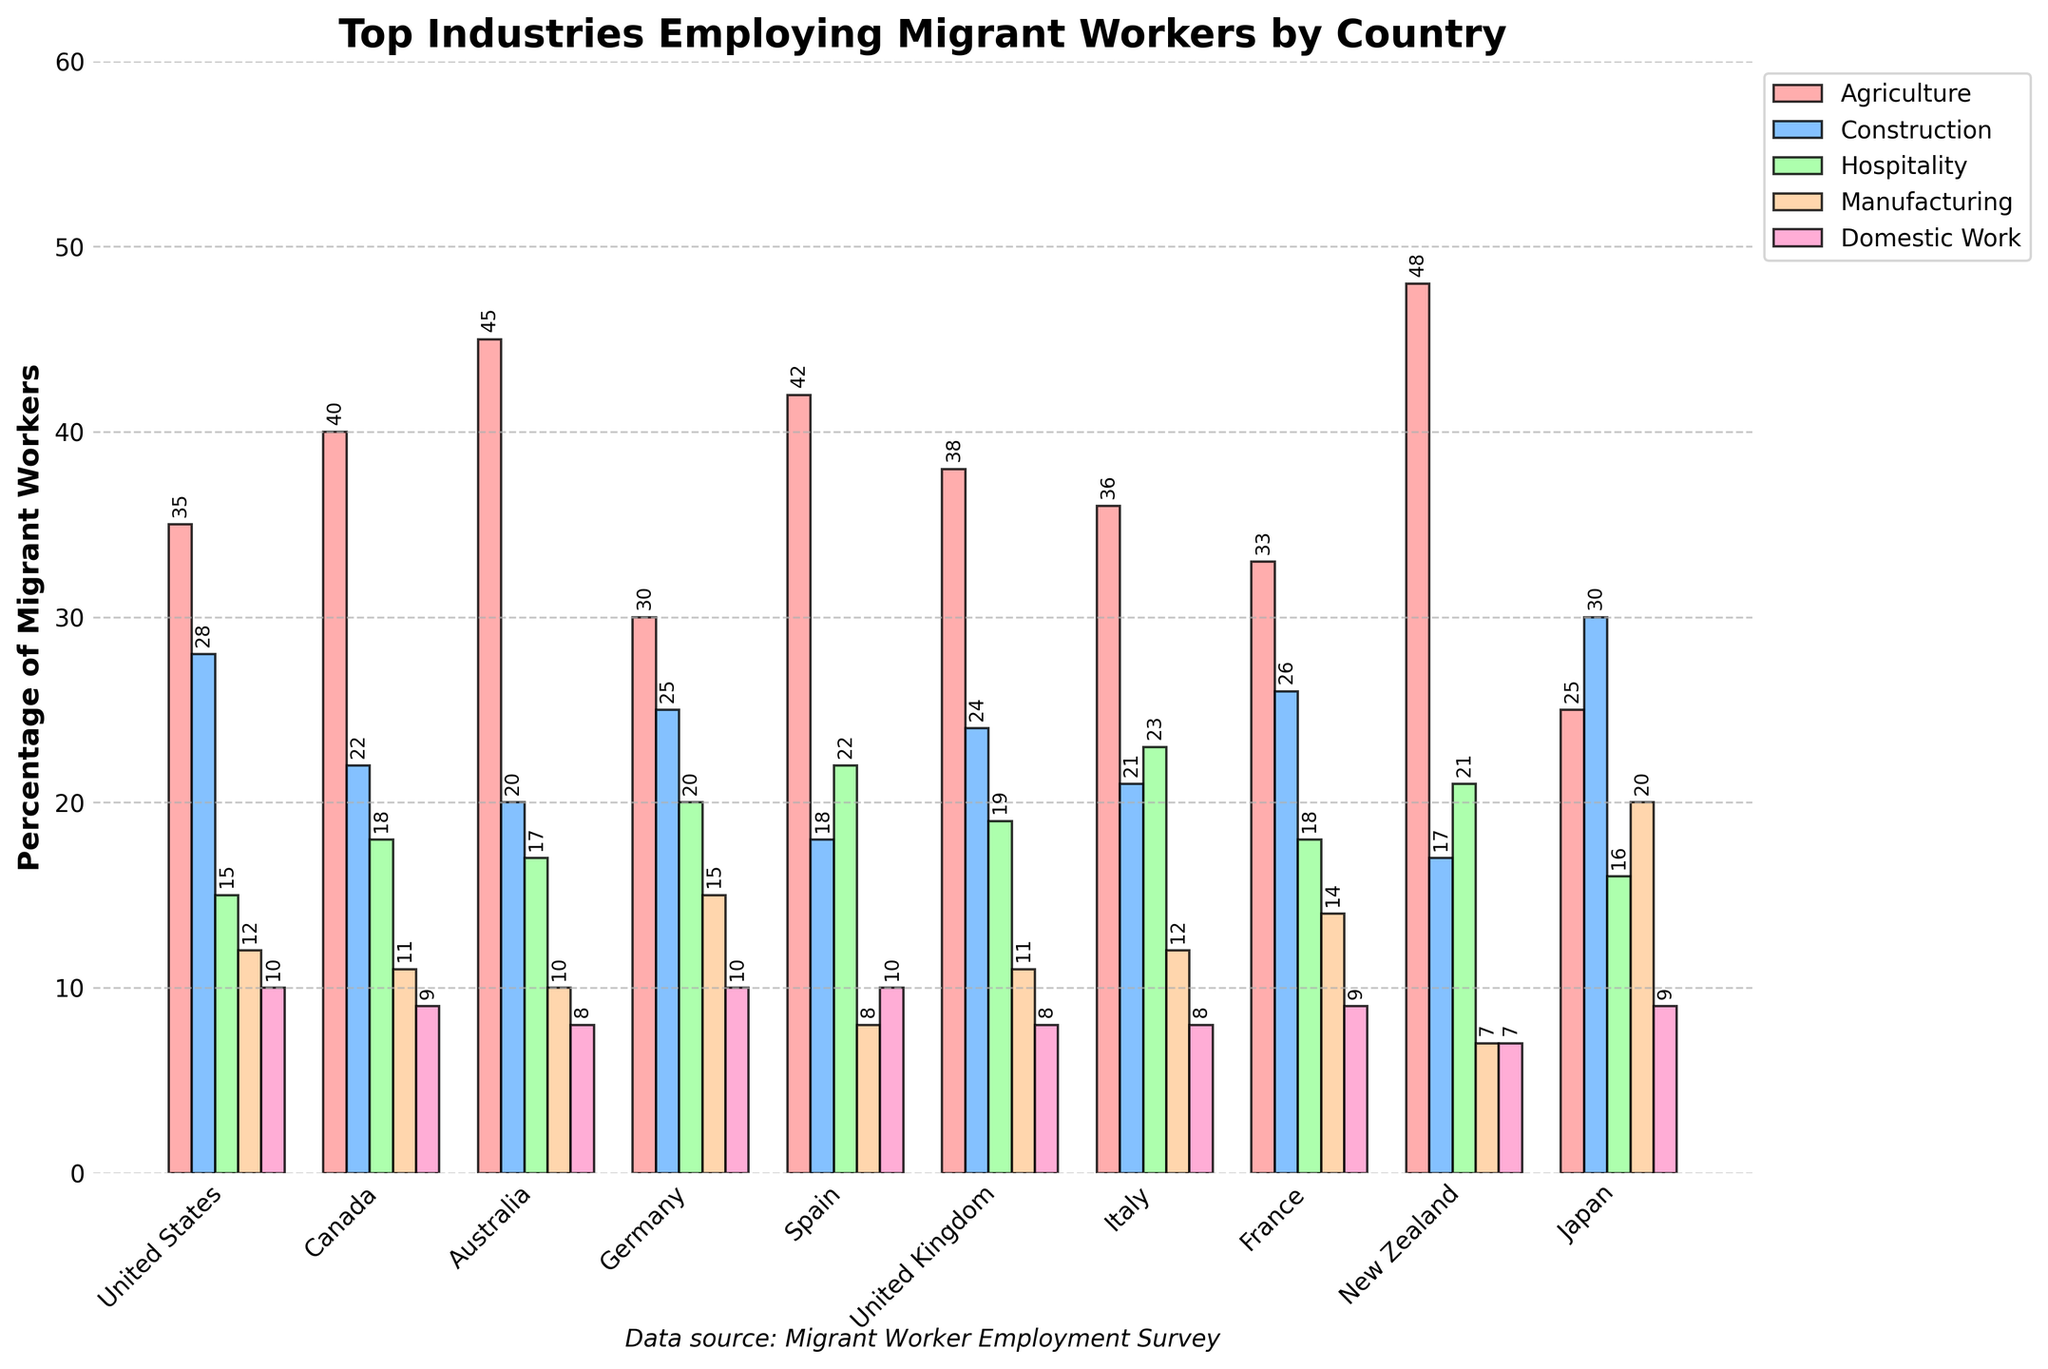Which country has the highest percentage of migrant workers employed in agriculture? The tallest bar in the agriculture category is observed for New Zealand.
Answer: New Zealand Which industry employs the most migrant workers in Japan? The highest bar for Japan is in the construction category.
Answer: Construction Compare the percentage of migrant workers in agriculture between the United States and Canada. Which country has a higher percentage? The bars show that Canada has a higher percentage of migrant workers in agriculture compared to the United States.
Answer: Canada What is the total percentage of migrant workers employed in manufacturing in Germany and France combined? Germany has 15% and France has 14% in manufacturing, so combined it is 15 + 14.
Answer: 29% Which country has the lowest percentage of migrant workers employed in domestic work? New Zealand has the lowest bar in the domestic work category.
Answer: New Zealand Among the countries listed, which has the second highest percentage of migrant workers employed in hospitality? The second tallest bar in hospitality is in Spain.
Answer: Spain Which country shows more even distribution of migrant workers across all industries, United Kingdom or Italy? The bars for the United Kingdom are more evenly distributed compared to Italy.
Answer: United Kingdom What is the average percentage of migrant workers employed in construction across all listed countries? Add the percentages for construction across all countries and divide by the number of countries: (28 + 22 + 20 + 25 + 18 + 24 + 21 + 26 + 17 + 30) / 10 = 23.1
Answer: 23.1 Is there any country where construction employs more migrant workers than agriculture? The bar for construction is higher than the bar for agriculture in Japan.
Answer: Japan Which industry employs the least migrant workers in Australia? The shortest bar for Australia is in domestic work.
Answer: Domestic Work 